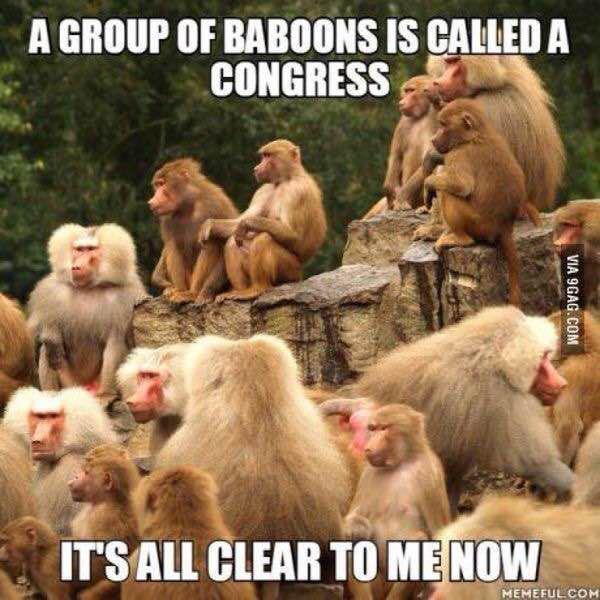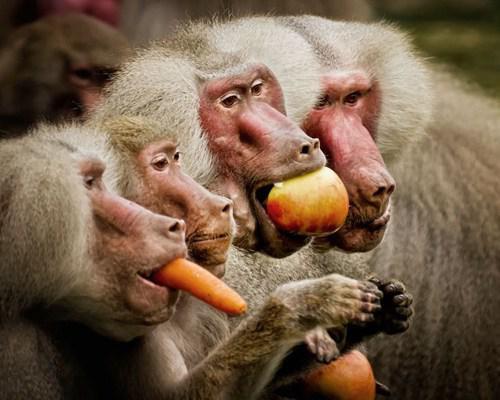The first image is the image on the left, the second image is the image on the right. For the images displayed, is the sentence "Each image contains exactly one monkey, and the monkeys on the right and left are the same approximate age [mature or immature]." factually correct? Answer yes or no. No. 